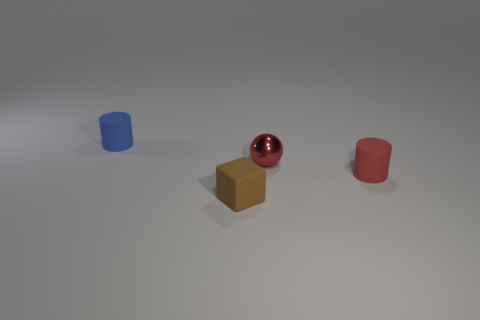Add 2 matte things. How many objects exist? 6 Subtract 1 red spheres. How many objects are left? 3 Subtract all cubes. How many objects are left? 3 Subtract all tiny brown matte cylinders. Subtract all brown things. How many objects are left? 3 Add 3 small metal balls. How many small metal balls are left? 4 Add 2 red metallic objects. How many red metallic objects exist? 3 